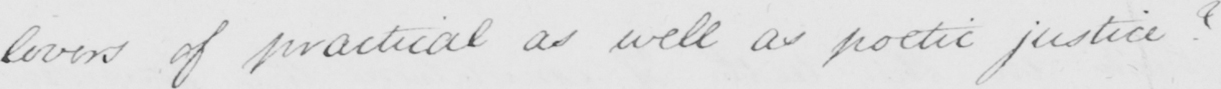What does this handwritten line say? lovers of practical as well as poetic justice ?   _ 